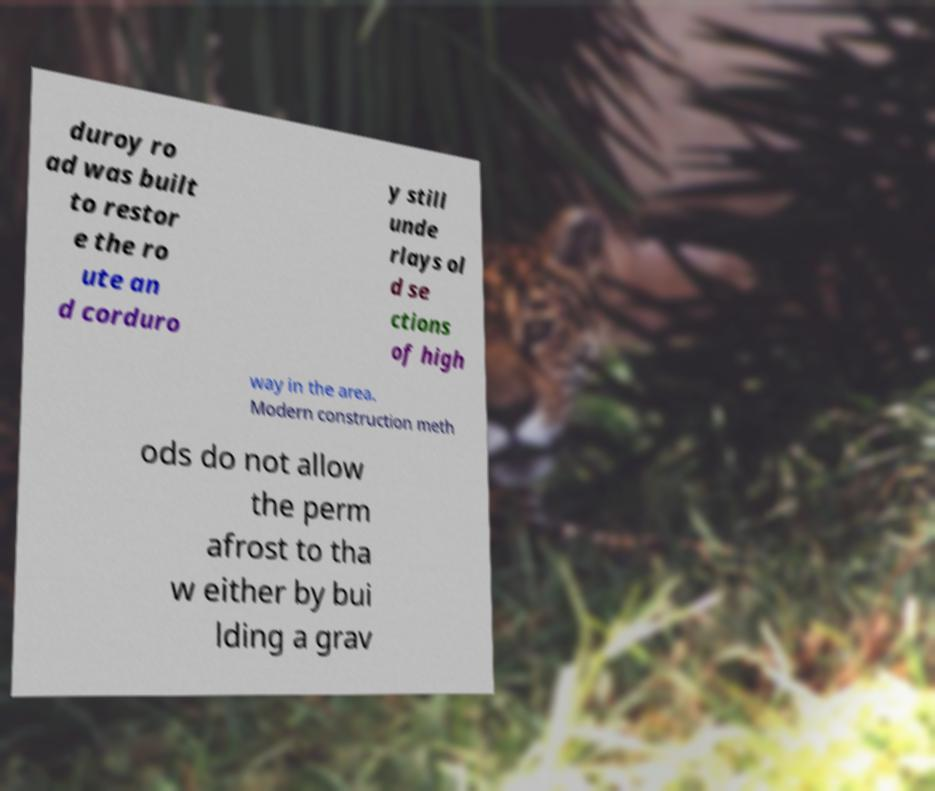Can you read and provide the text displayed in the image?This photo seems to have some interesting text. Can you extract and type it out for me? duroy ro ad was built to restor e the ro ute an d corduro y still unde rlays ol d se ctions of high way in the area. Modern construction meth ods do not allow the perm afrost to tha w either by bui lding a grav 